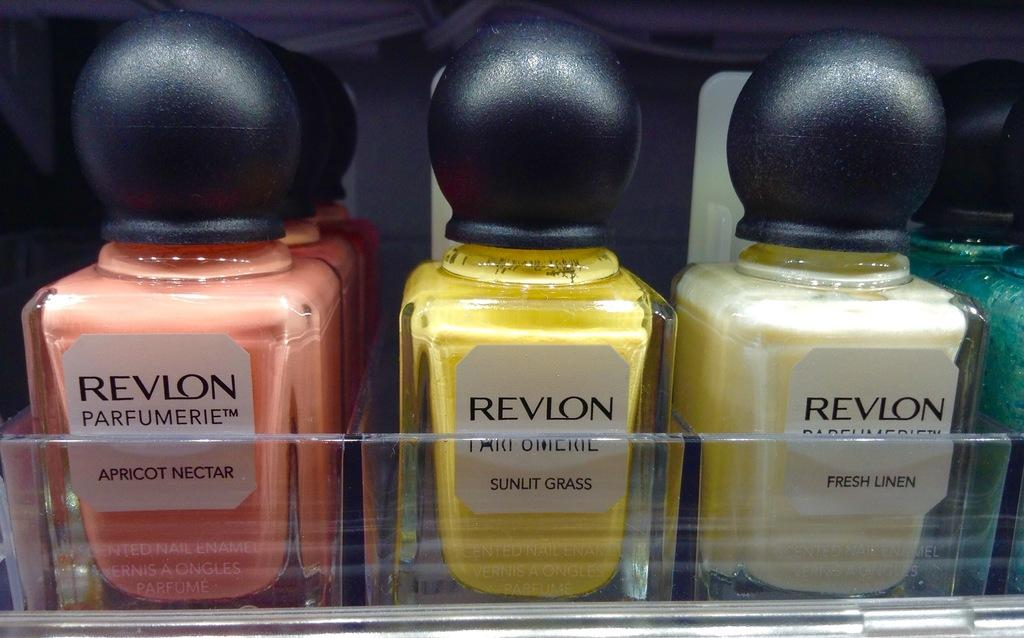<image>
Offer a succinct explanation of the picture presented. Three bottles of Revlon nail polish. The pink one is 'apricot nectar', yellow is 'sunlit grass' and cream 'fresh linen.' 